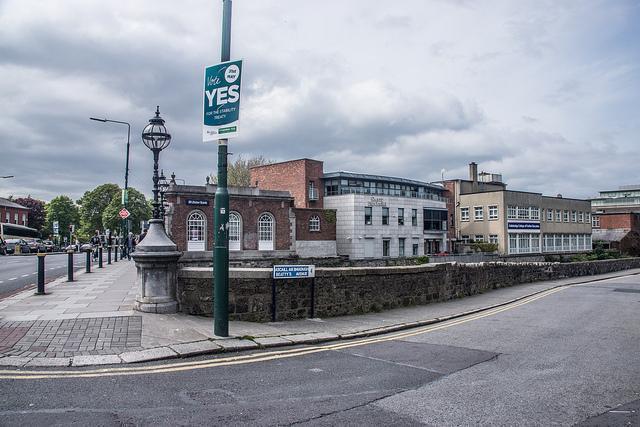The clouds here indicate what might happen?
Answer the question by selecting the correct answer among the 4 following choices.
Options: Tornado, wind tunnel, rain, sunny skies. Rain. What weather might be imminent here?
Pick the correct solution from the four options below to address the question.
Options: Tornado, sun, rain, earthquake. Rain. 